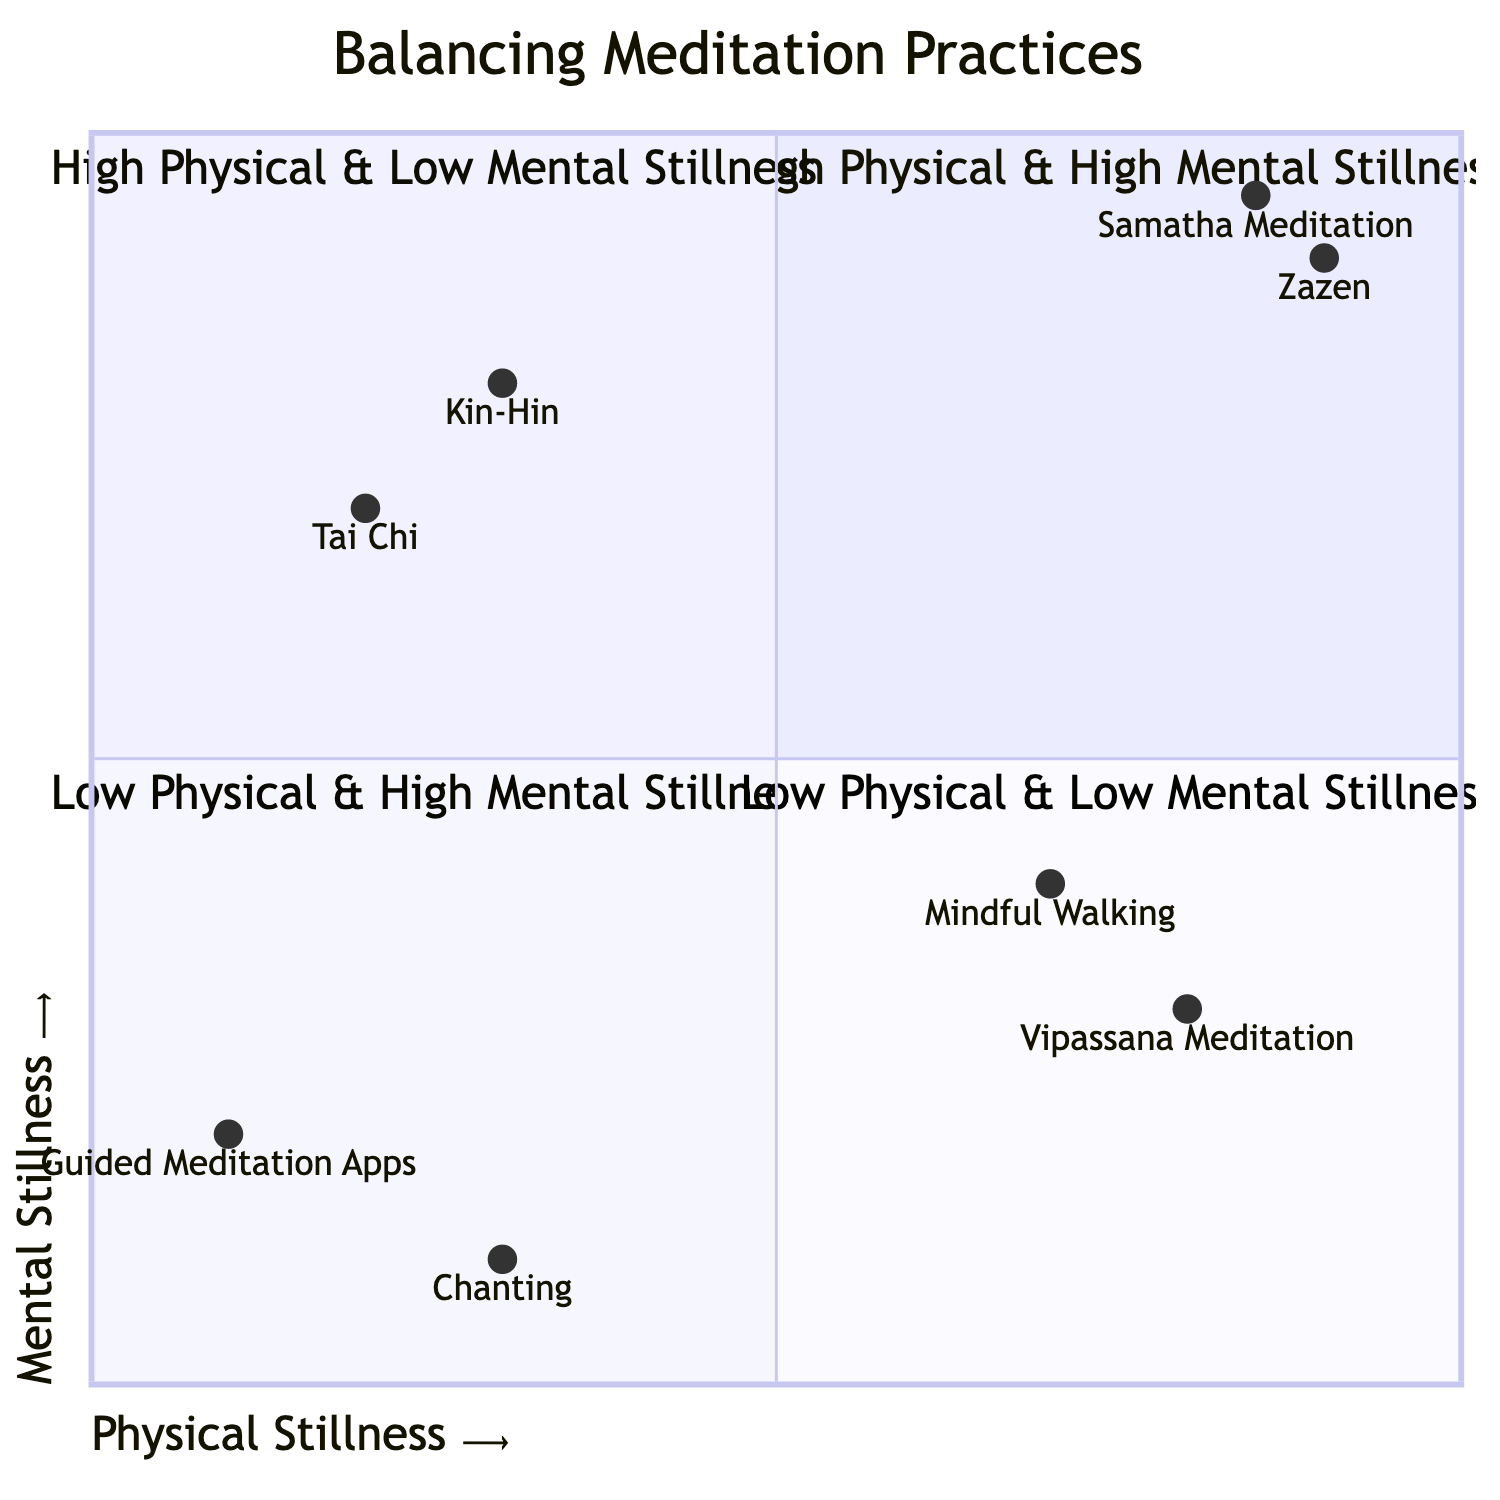What practices fall into the High Physical & High Mental Stillness quadrant? The High Physical & High Mental Stillness quadrant includes the practices Zazen and Samatha Meditation. These are specifically listed in this quadrant designation.
Answer: Zazen, Samatha Meditation Which quadrant contains the practice of Guided Meditation Apps? Guided Meditation Apps are correctly placed in the Low Physical & Low Mental Stillness quadrant, as specified in the diagram.
Answer: Low Physical & Low Mental Stillness How many practices focus on Low Physical & High Mental Stillness? There are two practices listed in the Low Physical & High Mental Stillness quadrant: Kin-Hin and Tai Chi. This can be counted directly from the description of the quadrant.
Answer: 2 What is the primary focus of the High Physical & Low Mental Stillness quadrant? The primary focus of this quadrant is on bodily stillness while allowing the mind to remain active and observational. This is explicitly stated in the description provided for this quadrant.
Answer: Bodily stillness Name one practice that falls into the Low Physical & Low Mental Stillness quadrant. The Low Physical & Low Mental Stillness quadrant includes Guided Meditation Apps or Chanting, both listed in that category.
Answer: Guided Meditation Apps In terms of physical stillness, which practice has the highest value? Among the listed practices, Zazen has the highest value for physical stillness at 0.9, as noted in the coordinate values for each practice.
Answer: Zazen What can be inferred about the practices in the Low Physical & High Mental Stillness quadrant? The practices in this quadrant, such as Kin-Hin and Tai Chi, emphasize movement while aiming for mental tranquility, highlighting a distinction from the other quadrants.
Answer: Movement with mental tranquility Which quadrant features practices that involve following external prompts? The Low Physical & Low Mental Stillness quadrant features practices involving following external prompts, as described in its description including Guided Meditation Apps and Chanting.
Answer: Low Physical & Low Mental Stillness 